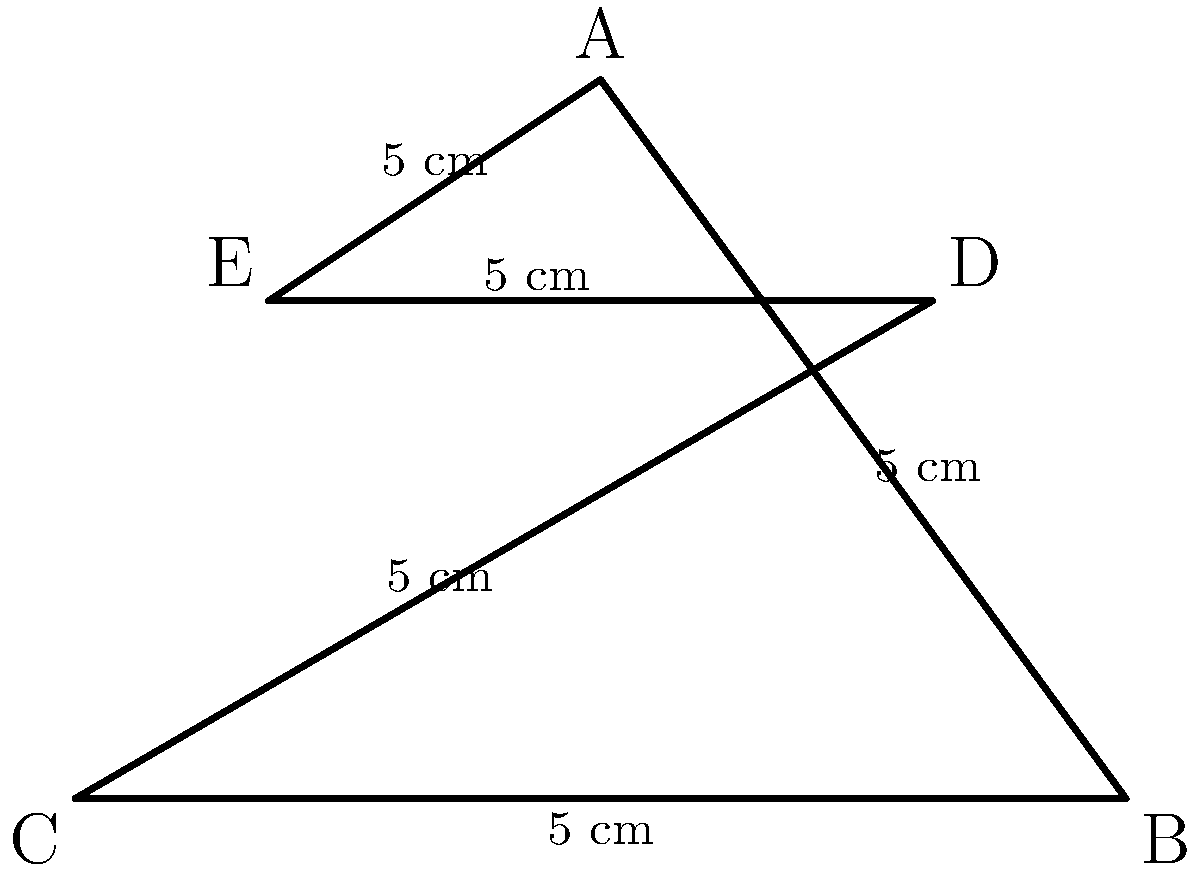In the iconic pentagram symbol from "The Crow," each side measures 5 cm. Calculate the perimeter of this mystical symbol. To calculate the perimeter of the pentagram, we need to follow these steps:

1) Identify the shape: The symbol is a regular pentagram, which has 5 equal sides.

2) Determine the length of each side: Given in the question, each side is 5 cm long.

3) Calculate the perimeter: The perimeter of any polygon is the sum of the lengths of all its sides. For a regular pentagon with 5 equal sides, we multiply the length of one side by 5.

   Perimeter $= 5 \times$ side length
              $= 5 \times 5$ cm
              $= 25$ cm

Therefore, the perimeter of the pentagram symbol is 25 cm.
Answer: 25 cm 